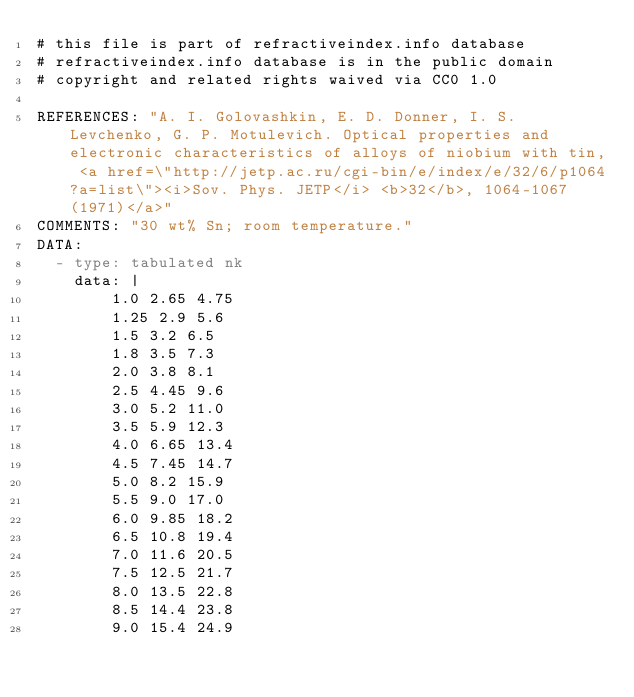<code> <loc_0><loc_0><loc_500><loc_500><_YAML_># this file is part of refractiveindex.info database
# refractiveindex.info database is in the public domain
# copyright and related rights waived via CC0 1.0

REFERENCES: "A. I. Golovashkin, E. D. Donner, I. S. Levchenko, G. P. Motulevich. Optical properties and electronic characteristics of alloys of niobium with tin, <a href=\"http://jetp.ac.ru/cgi-bin/e/index/e/32/6/p1064?a=list\"><i>Sov. Phys. JETP</i> <b>32</b>, 1064-1067 (1971)</a>"
COMMENTS: "30 wt% Sn; room temperature."
DATA:
  - type: tabulated nk
    data: |
        1.0 2.65 4.75
        1.25 2.9 5.6
        1.5 3.2 6.5
        1.8 3.5 7.3
        2.0 3.8 8.1
        2.5 4.45 9.6
        3.0 5.2 11.0
        3.5 5.9 12.3
        4.0 6.65 13.4
        4.5 7.45 14.7
        5.0 8.2 15.9
        5.5 9.0 17.0
        6.0 9.85 18.2
        6.5 10.8 19.4
        7.0 11.6 20.5
        7.5 12.5 21.7
        8.0 13.5 22.8
        8.5 14.4 23.8
        9.0 15.4 24.9
</code> 